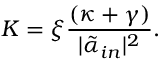<formula> <loc_0><loc_0><loc_500><loc_500>K = \xi \frac { ( \kappa + \gamma ) } { | \tilde { \alpha } _ { i n } | ^ { 2 } } .</formula> 